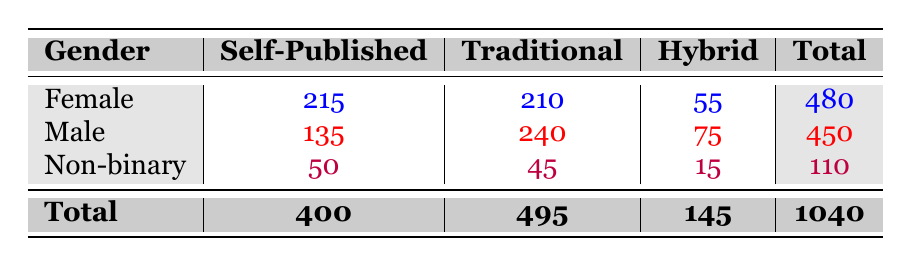What is the total number of self-published writers? The total number of self-published writers is obtained from the last row of the table. We see that there are 400 self-published writers in total.
Answer: 400 How many traditional writers are male? From the male row, we can see that there are 240 traditional writers reported.
Answer: 240 Which gender has the highest number of hybrid writers? Looking at the hybrid column, males have 75 hybrid writers, while females have 55, and non-binary have 15. Therefore, males have the highest number of hybrid writers.
Answer: Male What is the difference in the number of traditional writers between females and non-binary individuals? Female traditional writers number 210, while non-binary traditional writers total 45. The difference is calculated as 210 - 45 = 165.
Answer: 165 Is the number of self-published female writers greater than both male and non-binary combined? The number of self-published female writers is 215. The combined total of self-published males (135) and non-binary (50) equals 185. Since 215 > 185, the answer is yes.
Answer: Yes What percentage of total writers are self-published? The total number of writers is 1040, with 400 being self-published. The percentage is calculated as (400/1040) * 100, which simplifies to approximately 38.46%.
Answer: 38.46% If you combine hybrid writers from all genders, how many do you have? Hybrid writers total 55 for females, 75 for males, and 15 for non-binary, yielding 55 + 75 + 15 = 145 hybrid writers overall.
Answer: 145 Are there more traditional writers than self-published writers? The total number of traditional writers is 495, whereas the total number of self-published writers is 400. Since 495 > 400, the answer is yes.
Answer: Yes What is the average number of self-published writers among the three genders? To find this average, sum the number of self-published writers: 215 (female) + 135 (male) + 50 (non-binary) = 400, and divide by three, yielding an average of 133.33.
Answer: 133.33 